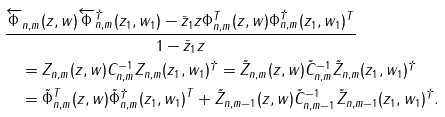Convert formula to latex. <formula><loc_0><loc_0><loc_500><loc_500>& \frac { \overleftarrow { \Phi } _ { n , m } ( z , w ) \overleftarrow { \Phi } ^ { \dagger } _ { n , m } ( z _ { 1 } , w _ { 1 } ) - \bar { z } _ { 1 } z \Phi _ { n , m } ^ { T } ( z , w ) \Phi ^ { \dagger } _ { n , m } ( z _ { 1 } , w _ { 1 } ) ^ { T } } { 1 - \bar { z } _ { 1 } z } \\ & \quad = Z _ { n , m } ( z , w ) C _ { n , m } ^ { - 1 } Z _ { n , m } ( z _ { 1 } , w _ { 1 } ) ^ { \dagger } = \tilde { Z } _ { n , m } ( z , w ) \tilde { C } _ { n , m } ^ { - 1 } \tilde { Z } _ { n , m } ( z _ { 1 } , w _ { 1 } ) ^ { \dagger } \\ & \quad = \tilde { \Phi } _ { n , m } ^ { T } ( z , w ) \tilde { \Phi } ^ { \dagger } _ { n , m } ( z _ { 1 } , w _ { 1 } ) ^ { T } + \tilde { Z } _ { n , m - 1 } ( z , w ) \tilde { C } _ { n , m - 1 } ^ { - 1 } \tilde { Z } _ { n , m - 1 } ( z _ { 1 } , w _ { 1 } ) ^ { \dagger } .</formula> 